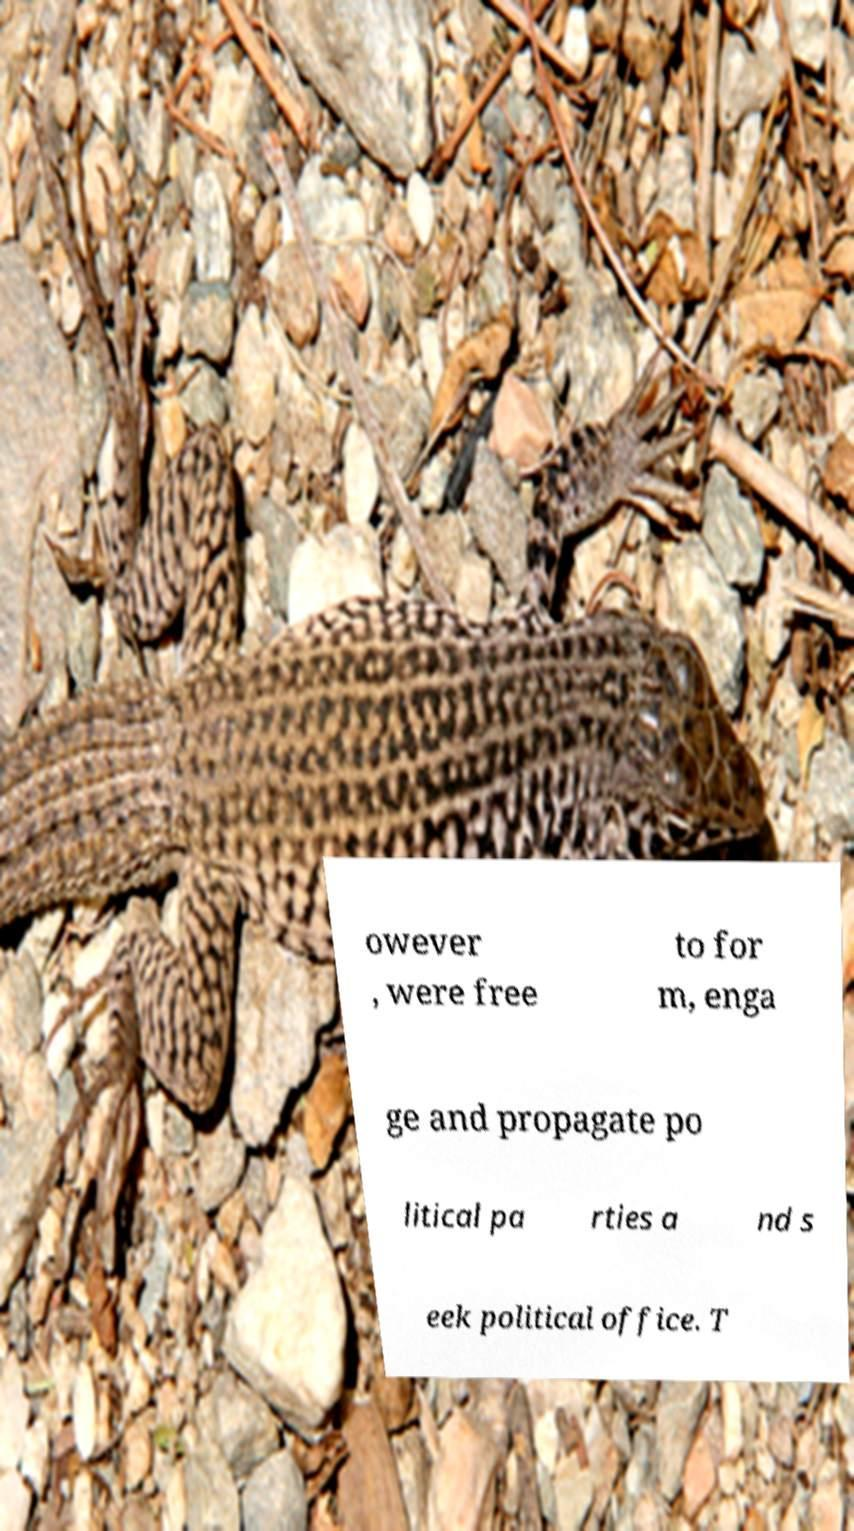What messages or text are displayed in this image? I need them in a readable, typed format. owever , were free to for m, enga ge and propagate po litical pa rties a nd s eek political office. T 